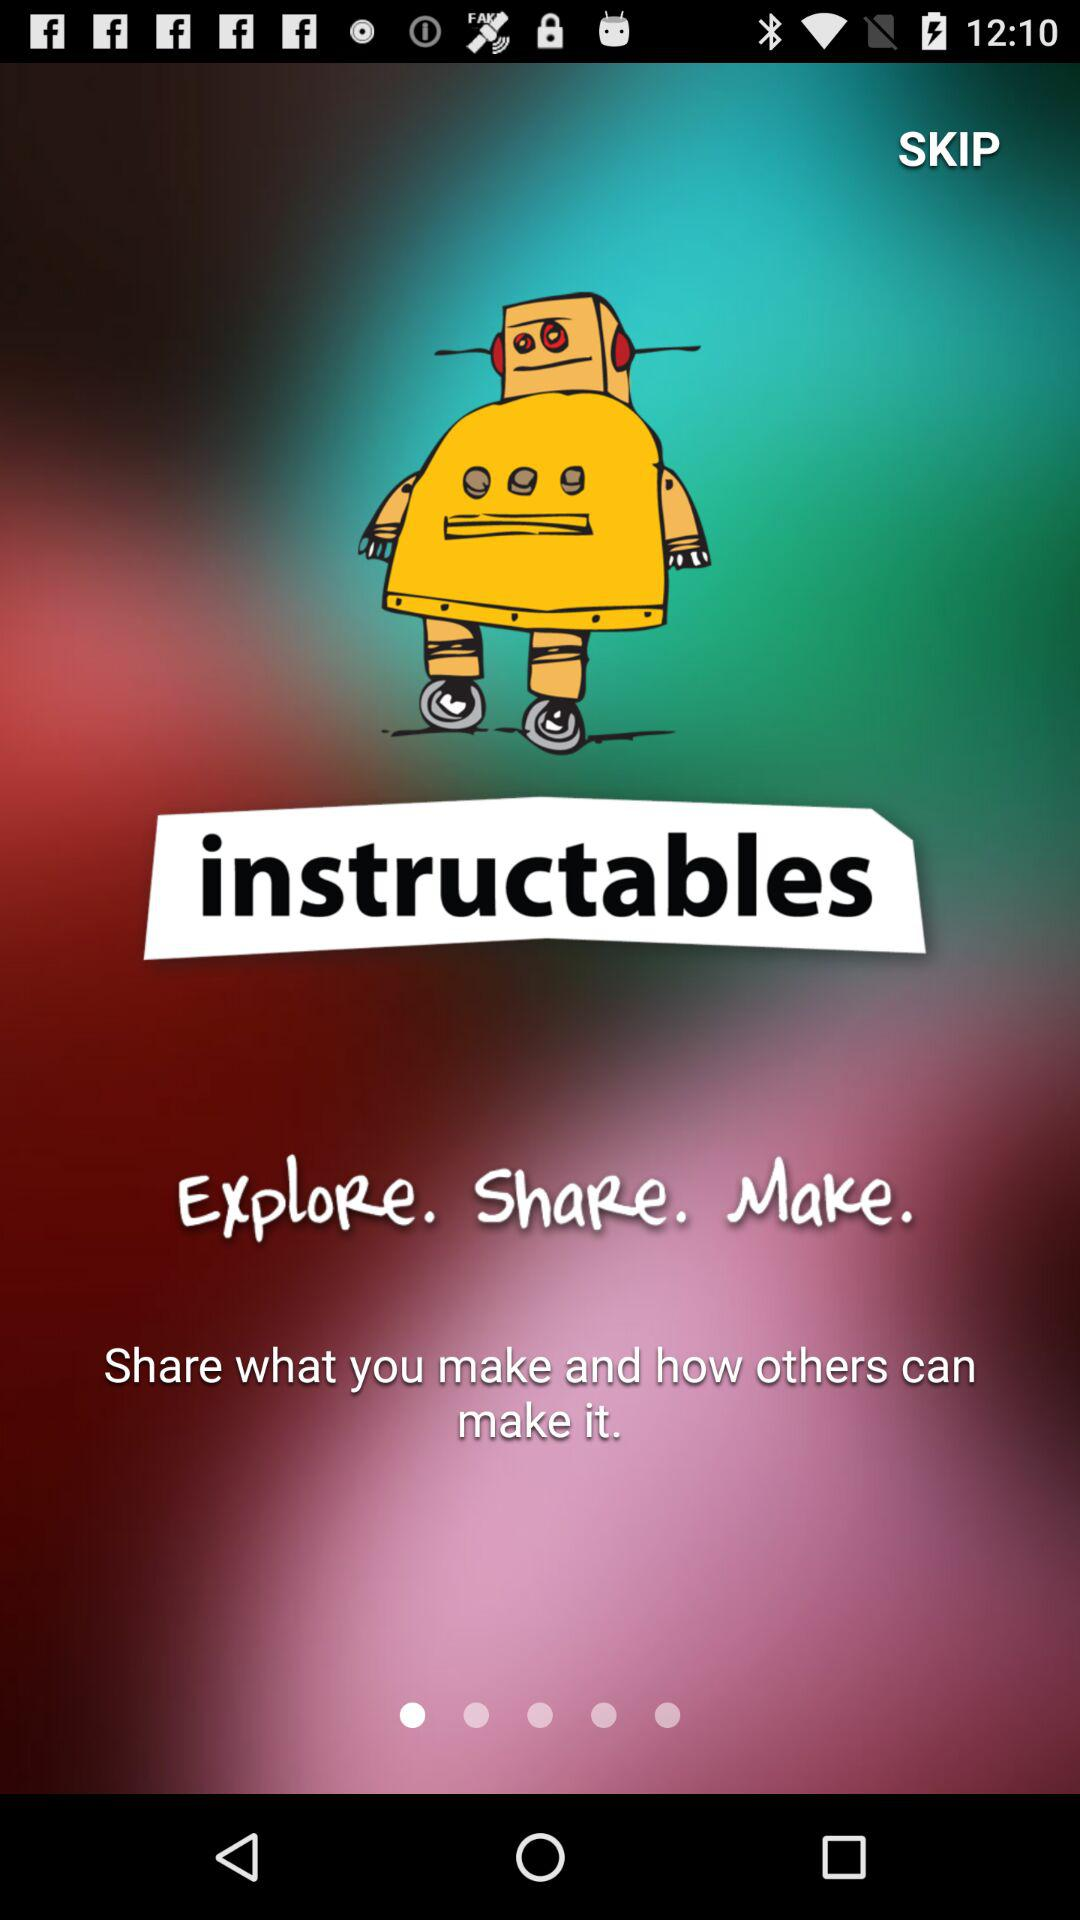What is the name of the application? The name of the application is "instructables". 